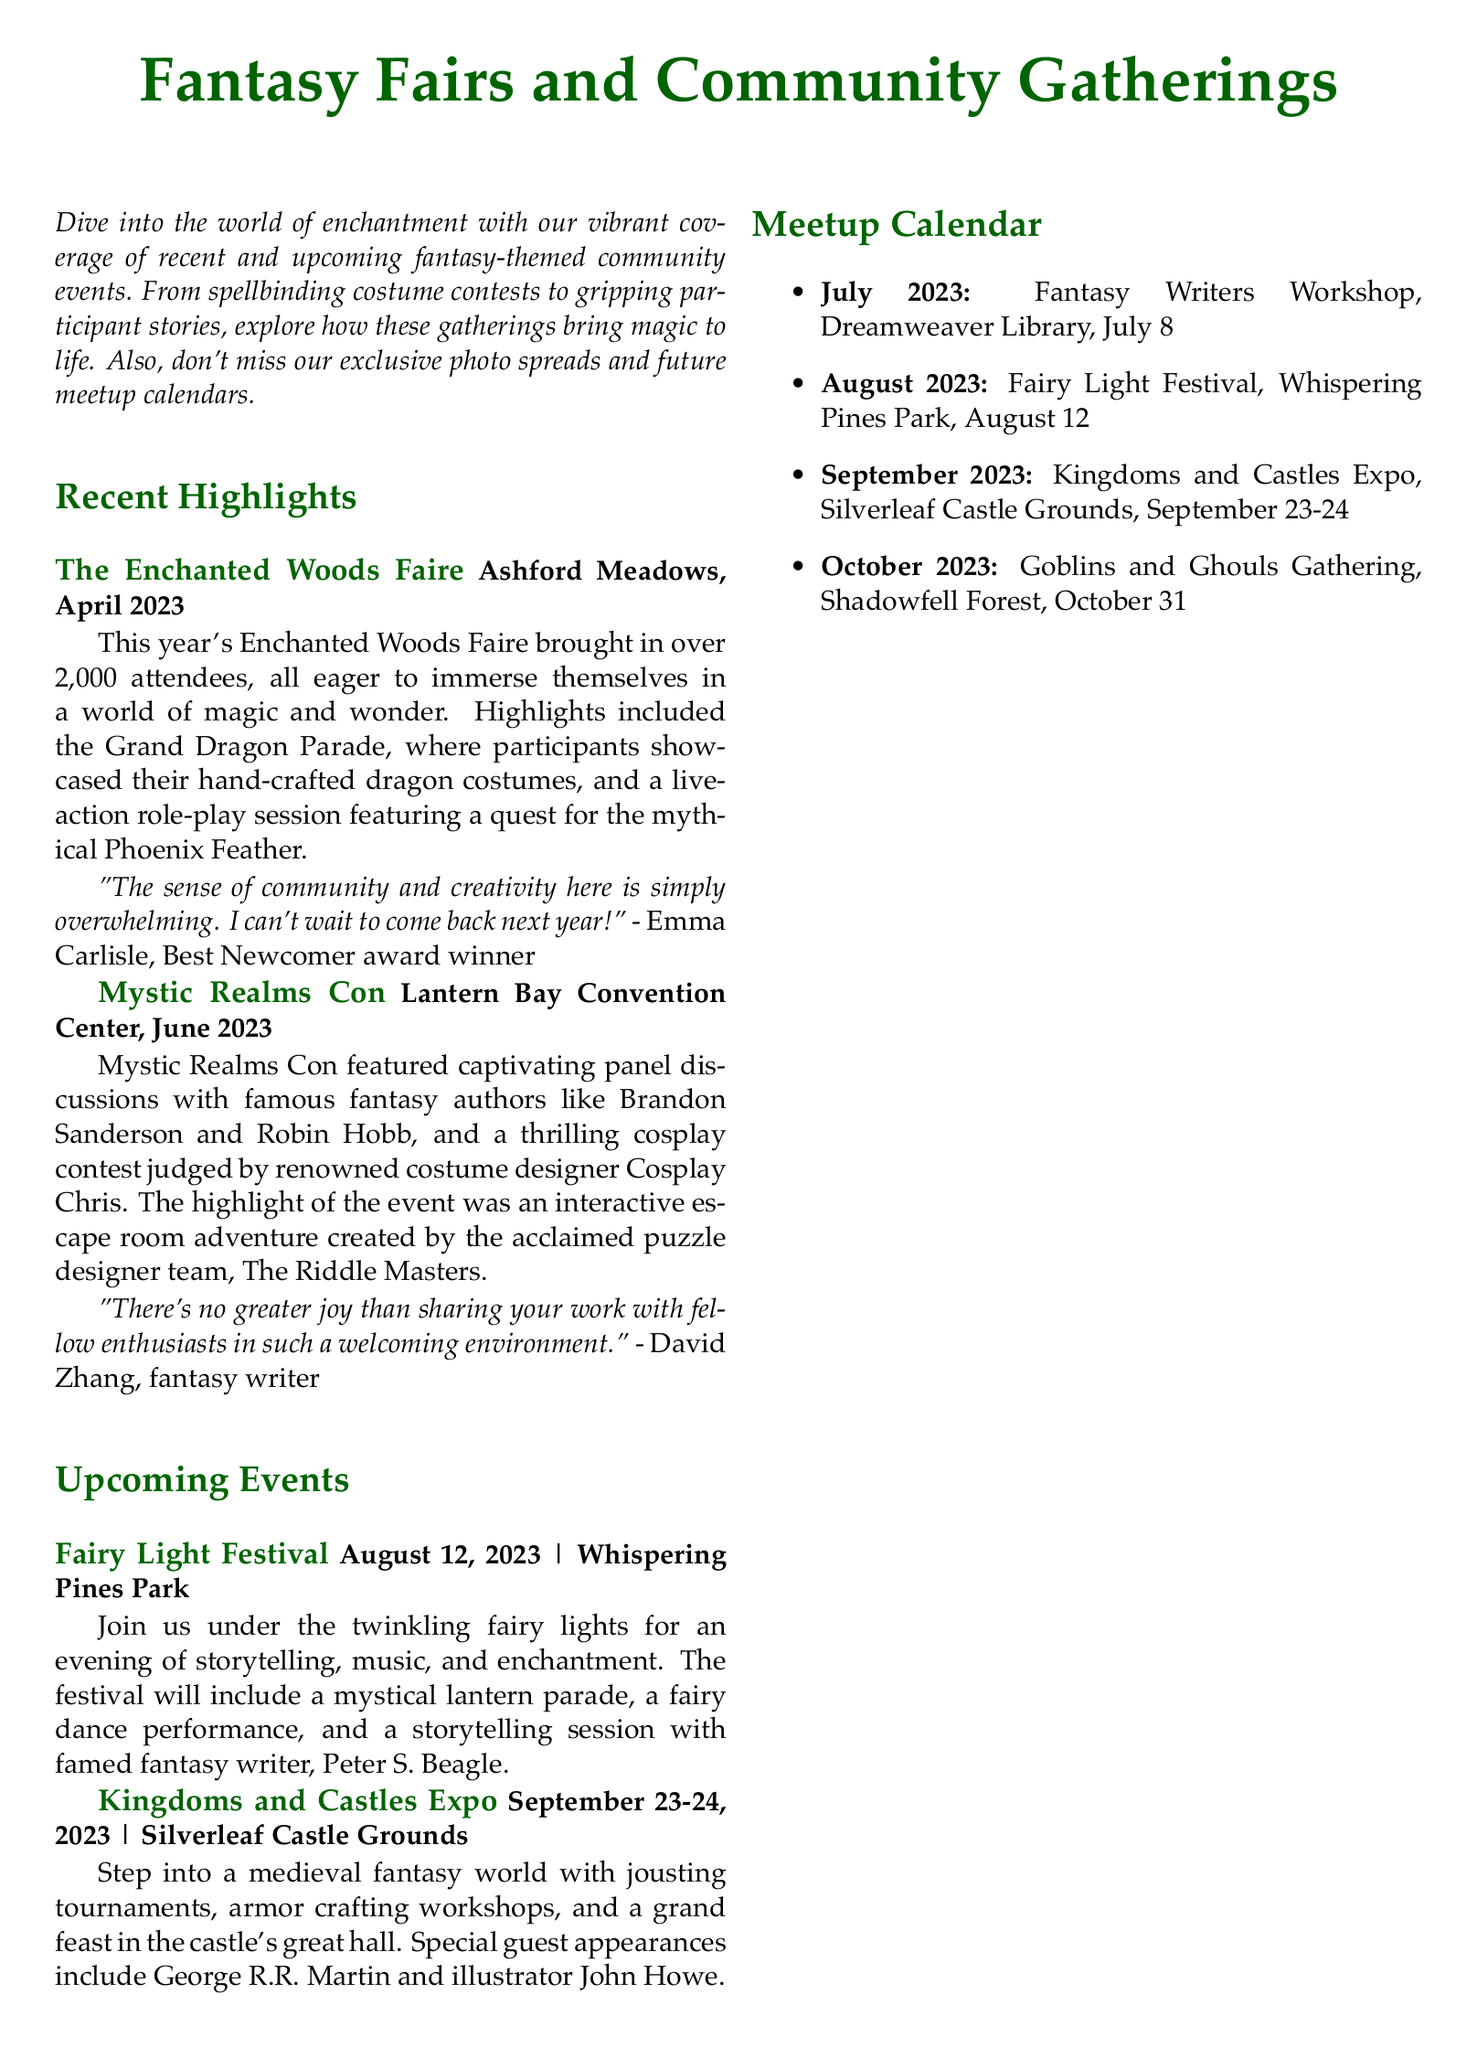What was the date of the Enchanted Woods Faire? The Enchanted Woods Faire took place in April 2023, as stated in the document.
Answer: April 2023 How many attendees were reported at the Mystic Realms Con? The document states that this event featured captivating panel discussions and a cosplay contest, with no specific number of attendees mentioned for this event.
Answer: Not mentioned Who was a special guest at the Kingdoms and Castles Expo? The document lists George R.R. Martin as one of the special guests at this expo.
Answer: George R.R. Martin What is featured at the Fairy Light Festival? The Fairy Light Festival includes storytelling, music, and a lantern parade, according to the details provided in the document.
Answer: Storytelling, music, and a lantern parade What award did Emma Carlisle win? The document mentions that Emma Carlisle was the Best Newcomer award winner at the Enchanted Woods Faire.
Answer: Best Newcomer Which two fantasy authors were featured in panel discussions during Mystic Realms Con? The panel discussions featured Brandon Sanderson and Robin Hobb, as stated in the document.
Answer: Brandon Sanderson and Robin Hobb When is the Goblins and Ghouls Gathering scheduled? The document states that the Goblins and Ghouls Gathering will take place on October 31, 2023.
Answer: October 31, 2023 What year will the Fairy Light Festival take place? The document specifies the date for the Fairy Light Festival as August 12, 2023.
Answer: 2023 